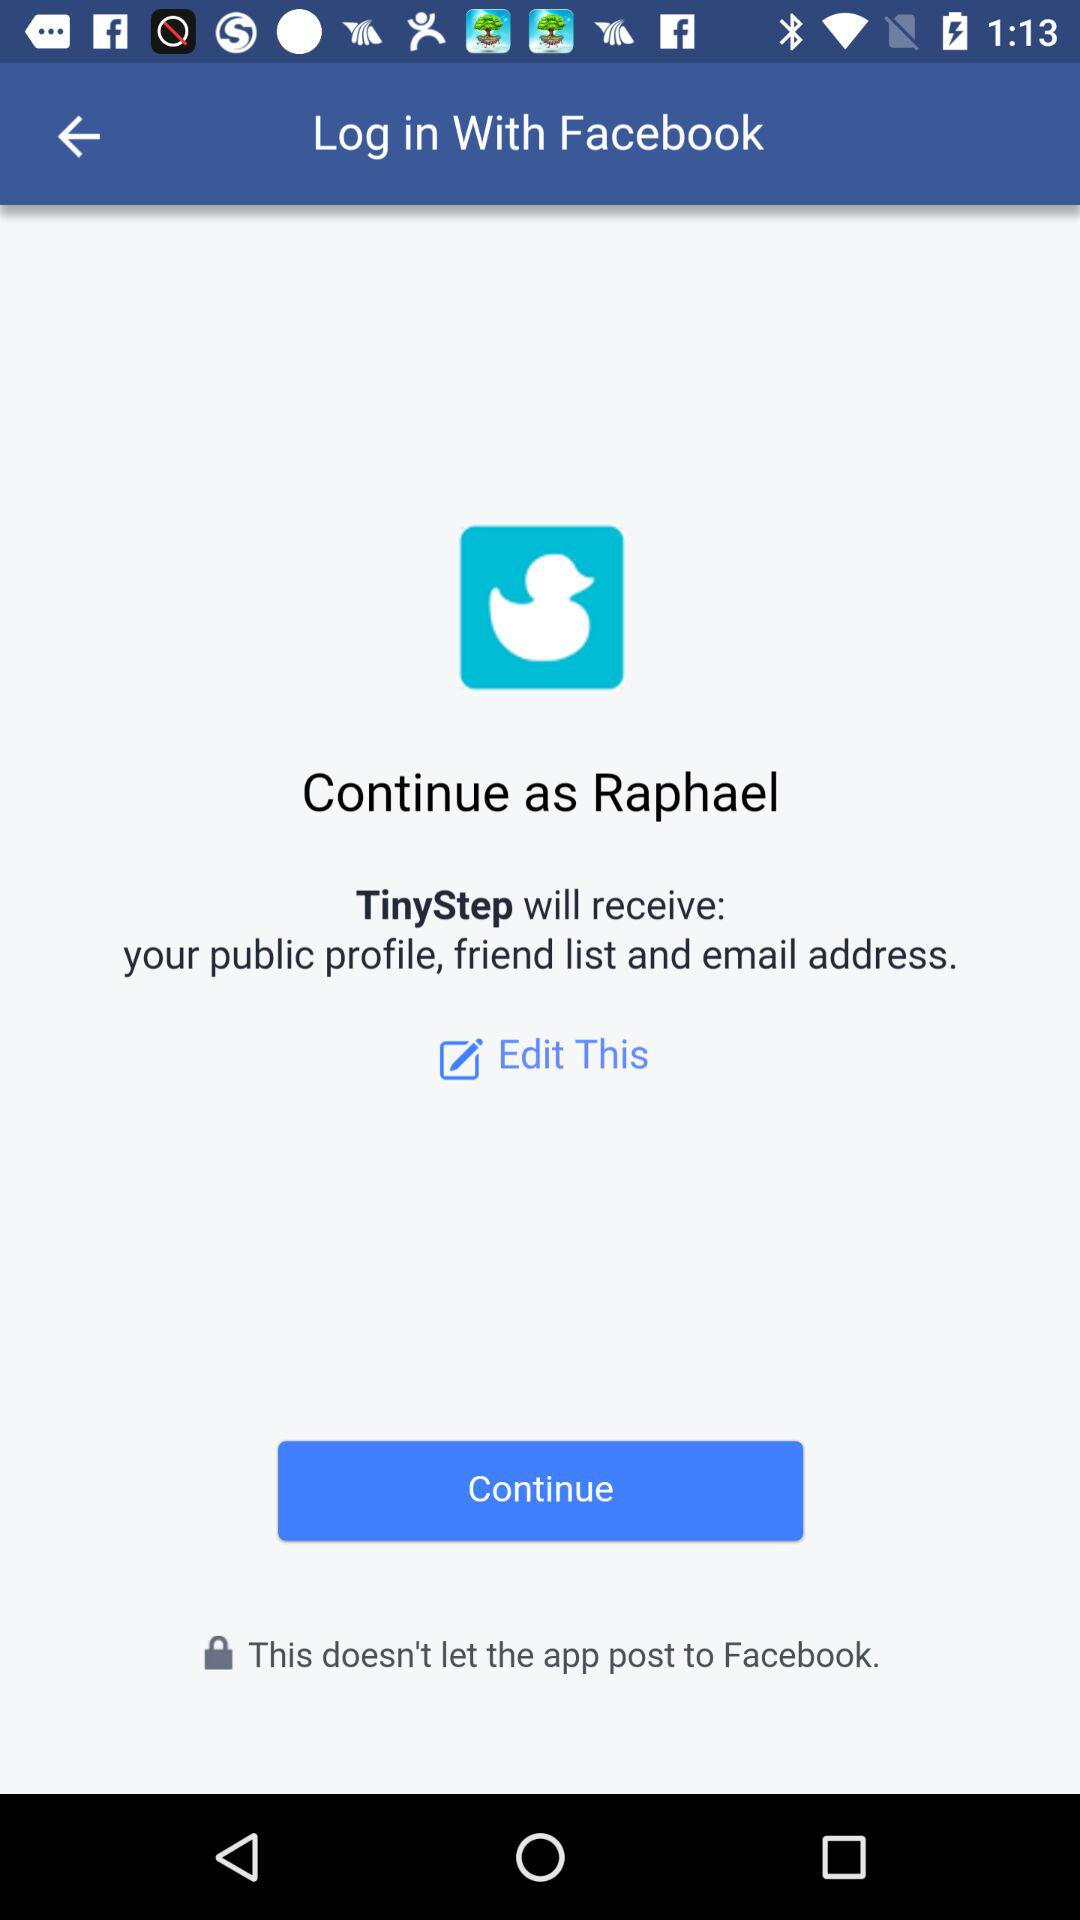Through what account can logging in be done? Logging in can be done through "Facebook". 